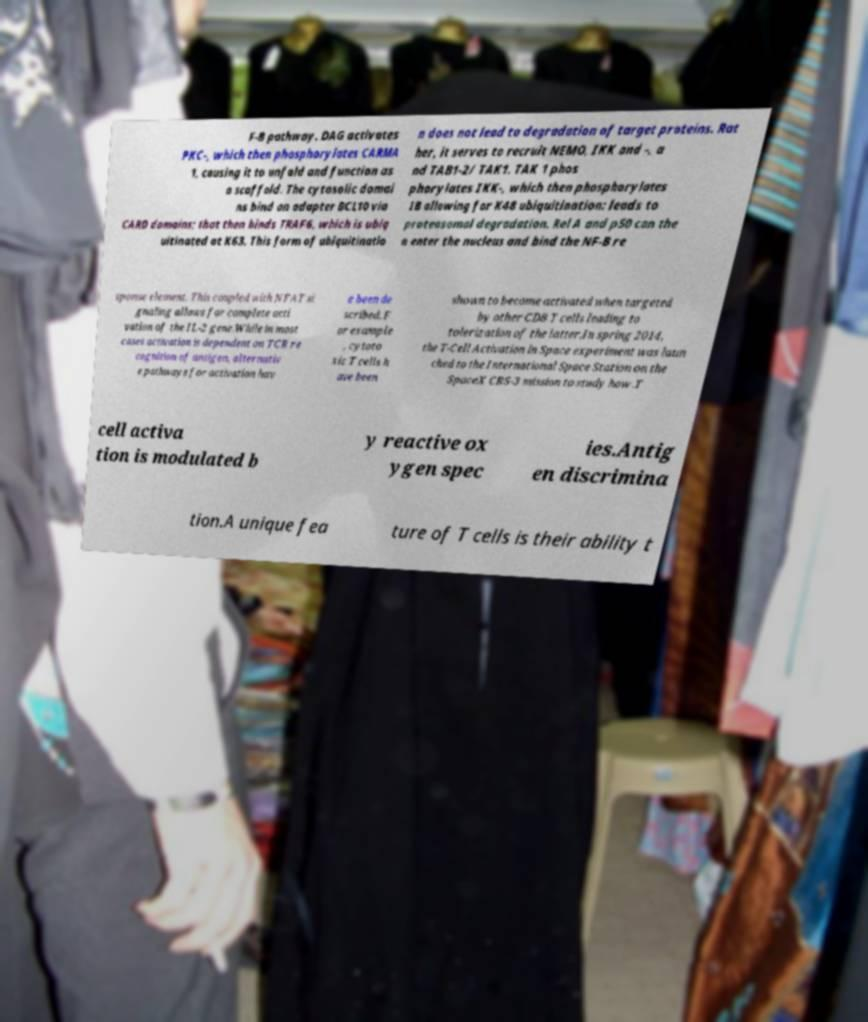Could you assist in decoding the text presented in this image and type it out clearly? F-B pathway. DAG activates PKC-, which then phosphorylates CARMA 1, causing it to unfold and function as a scaffold. The cytosolic domai ns bind an adapter BCL10 via CARD domains; that then binds TRAF6, which is ubiq uitinated at K63. This form of ubiquitinatio n does not lead to degradation of target proteins. Rat her, it serves to recruit NEMO, IKK and -, a nd TAB1-2/ TAK1. TAK 1 phos phorylates IKK-, which then phosphorylates IB allowing for K48 ubiquitination: leads to proteasomal degradation. Rel A and p50 can the n enter the nucleus and bind the NF-B re sponse element. This coupled with NFAT si gnaling allows for complete acti vation of the IL-2 gene.While in most cases activation is dependent on TCR re cognition of antigen, alternativ e pathways for activation hav e been de scribed. F or example , cytoto xic T cells h ave been shown to become activated when targeted by other CD8 T cells leading to tolerization of the latter.In spring 2014, the T-Cell Activation in Space experiment was laun ched to the International Space Station on the SpaceX CRS-3 mission to study how .T cell activa tion is modulated b y reactive ox ygen spec ies.Antig en discrimina tion.A unique fea ture of T cells is their ability t 